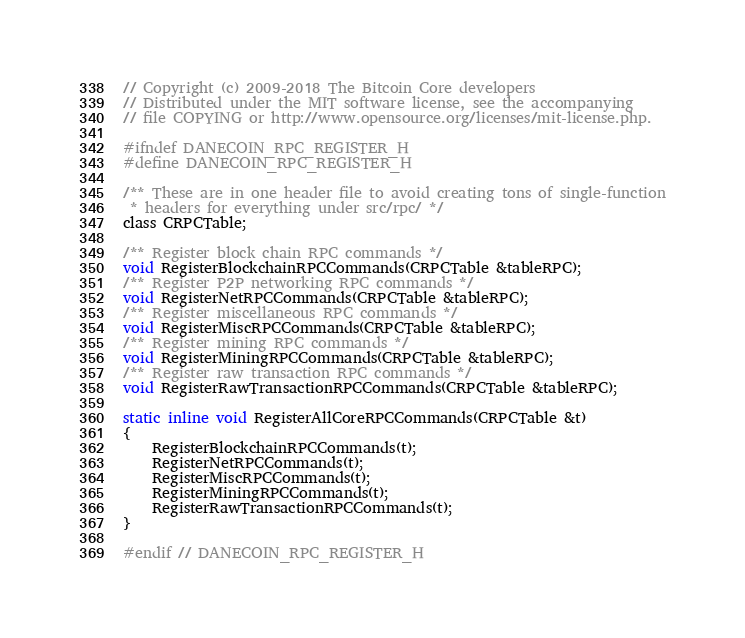Convert code to text. <code><loc_0><loc_0><loc_500><loc_500><_C_>// Copyright (c) 2009-2018 The Bitcoin Core developers
// Distributed under the MIT software license, see the accompanying
// file COPYING or http://www.opensource.org/licenses/mit-license.php.

#ifndef DANECOIN_RPC_REGISTER_H
#define DANECOIN_RPC_REGISTER_H

/** These are in one header file to avoid creating tons of single-function
 * headers for everything under src/rpc/ */
class CRPCTable;

/** Register block chain RPC commands */
void RegisterBlockchainRPCCommands(CRPCTable &tableRPC);
/** Register P2P networking RPC commands */
void RegisterNetRPCCommands(CRPCTable &tableRPC);
/** Register miscellaneous RPC commands */
void RegisterMiscRPCCommands(CRPCTable &tableRPC);
/** Register mining RPC commands */
void RegisterMiningRPCCommands(CRPCTable &tableRPC);
/** Register raw transaction RPC commands */
void RegisterRawTransactionRPCCommands(CRPCTable &tableRPC);

static inline void RegisterAllCoreRPCCommands(CRPCTable &t)
{
    RegisterBlockchainRPCCommands(t);
    RegisterNetRPCCommands(t);
    RegisterMiscRPCCommands(t);
    RegisterMiningRPCCommands(t);
    RegisterRawTransactionRPCCommands(t);
}

#endif // DANECOIN_RPC_REGISTER_H
</code> 